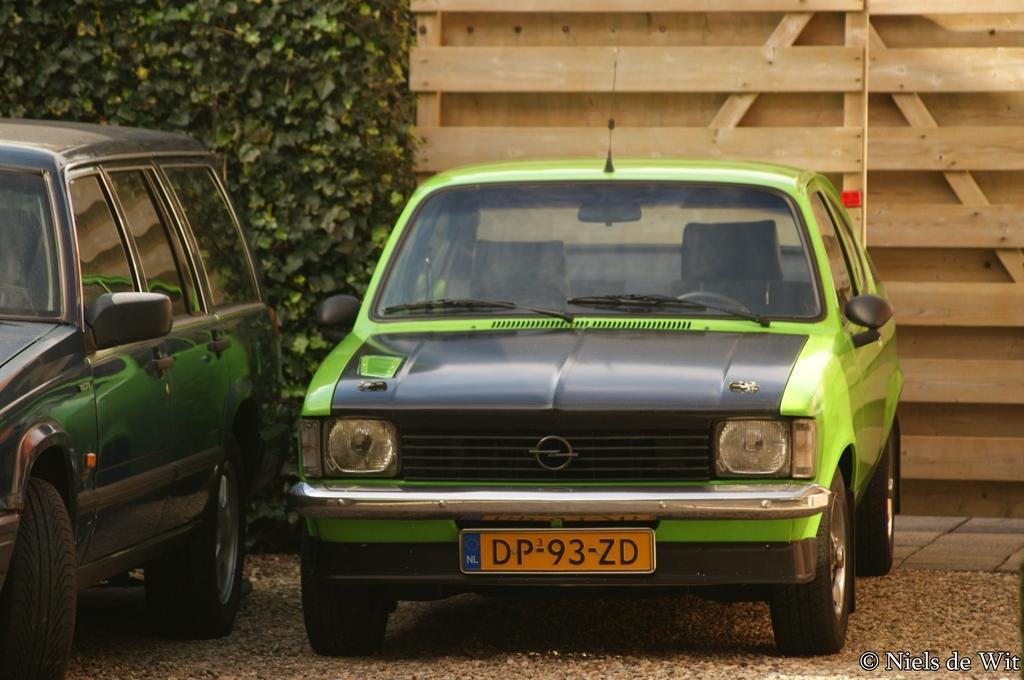How many cars are visible in the image? There are two cars in the image. What is located on the left side of the image? There is a tree on the left side of the image. What material is present on the right side of the image? There is wood on the right side of the image. Where can some text be found in the image? The text is located at the right bottom of the image. What type of copper utensil is being used on the stove in the image? There is no copper utensil or stove present in the image. What time of day is depicted in the image? The time of day is not mentioned or depicted in the image. 